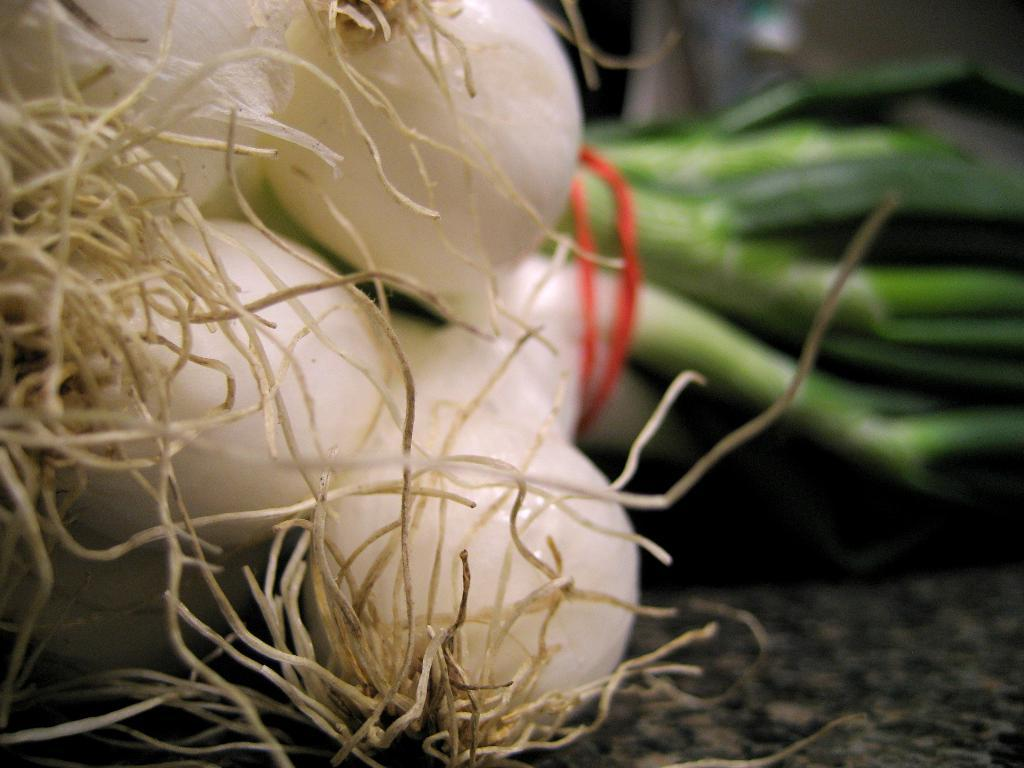What type of food items are on the platform in the image? There are onions on a platform in the image. Can you describe the background of the image? The background of the image is blurred. What position does the quill take in the image? There is no quill present in the image. How does the blurred background affect the sleep quality of the onions? The onions do not sleep, and the blurred background does not affect their sleep quality. 